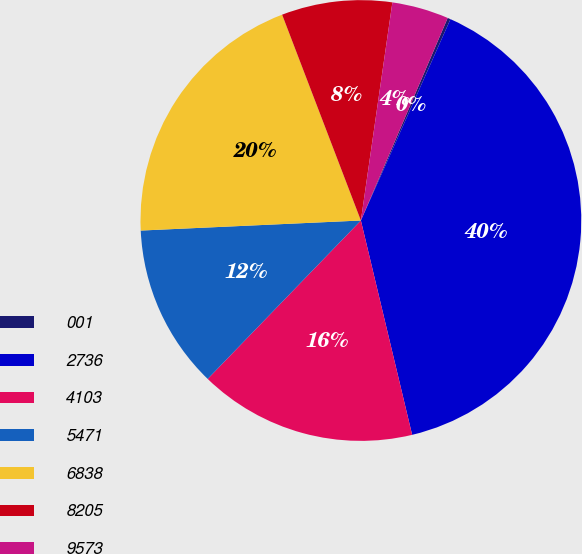Convert chart. <chart><loc_0><loc_0><loc_500><loc_500><pie_chart><fcel>001<fcel>2736<fcel>4103<fcel>5471<fcel>6838<fcel>8205<fcel>9573<nl><fcel>0.22%<fcel>39.6%<fcel>15.97%<fcel>12.04%<fcel>19.91%<fcel>8.1%<fcel>4.16%<nl></chart> 